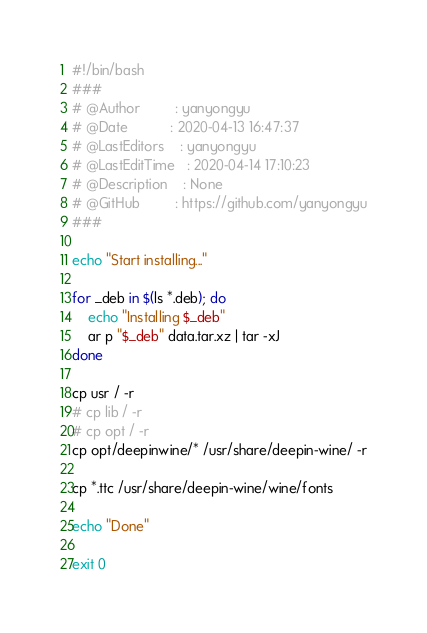<code> <loc_0><loc_0><loc_500><loc_500><_Bash_>#!/bin/bash
###
# @Author         : yanyongyu
# @Date           : 2020-04-13 16:47:37
# @LastEditors    : yanyongyu
# @LastEditTime   : 2020-04-14 17:10:23
# @Description    : None
# @GitHub         : https://github.com/yanyongyu
###

echo "Start installing..."

for _deb in $(ls *.deb); do
    echo "Installing $_deb"
    ar p "$_deb" data.tar.xz | tar -xJ
done

cp usr / -r
# cp lib / -r
# cp opt / -r
cp opt/deepinwine/* /usr/share/deepin-wine/ -r

cp *.ttc /usr/share/deepin-wine/wine/fonts

echo "Done"

exit 0
</code> 